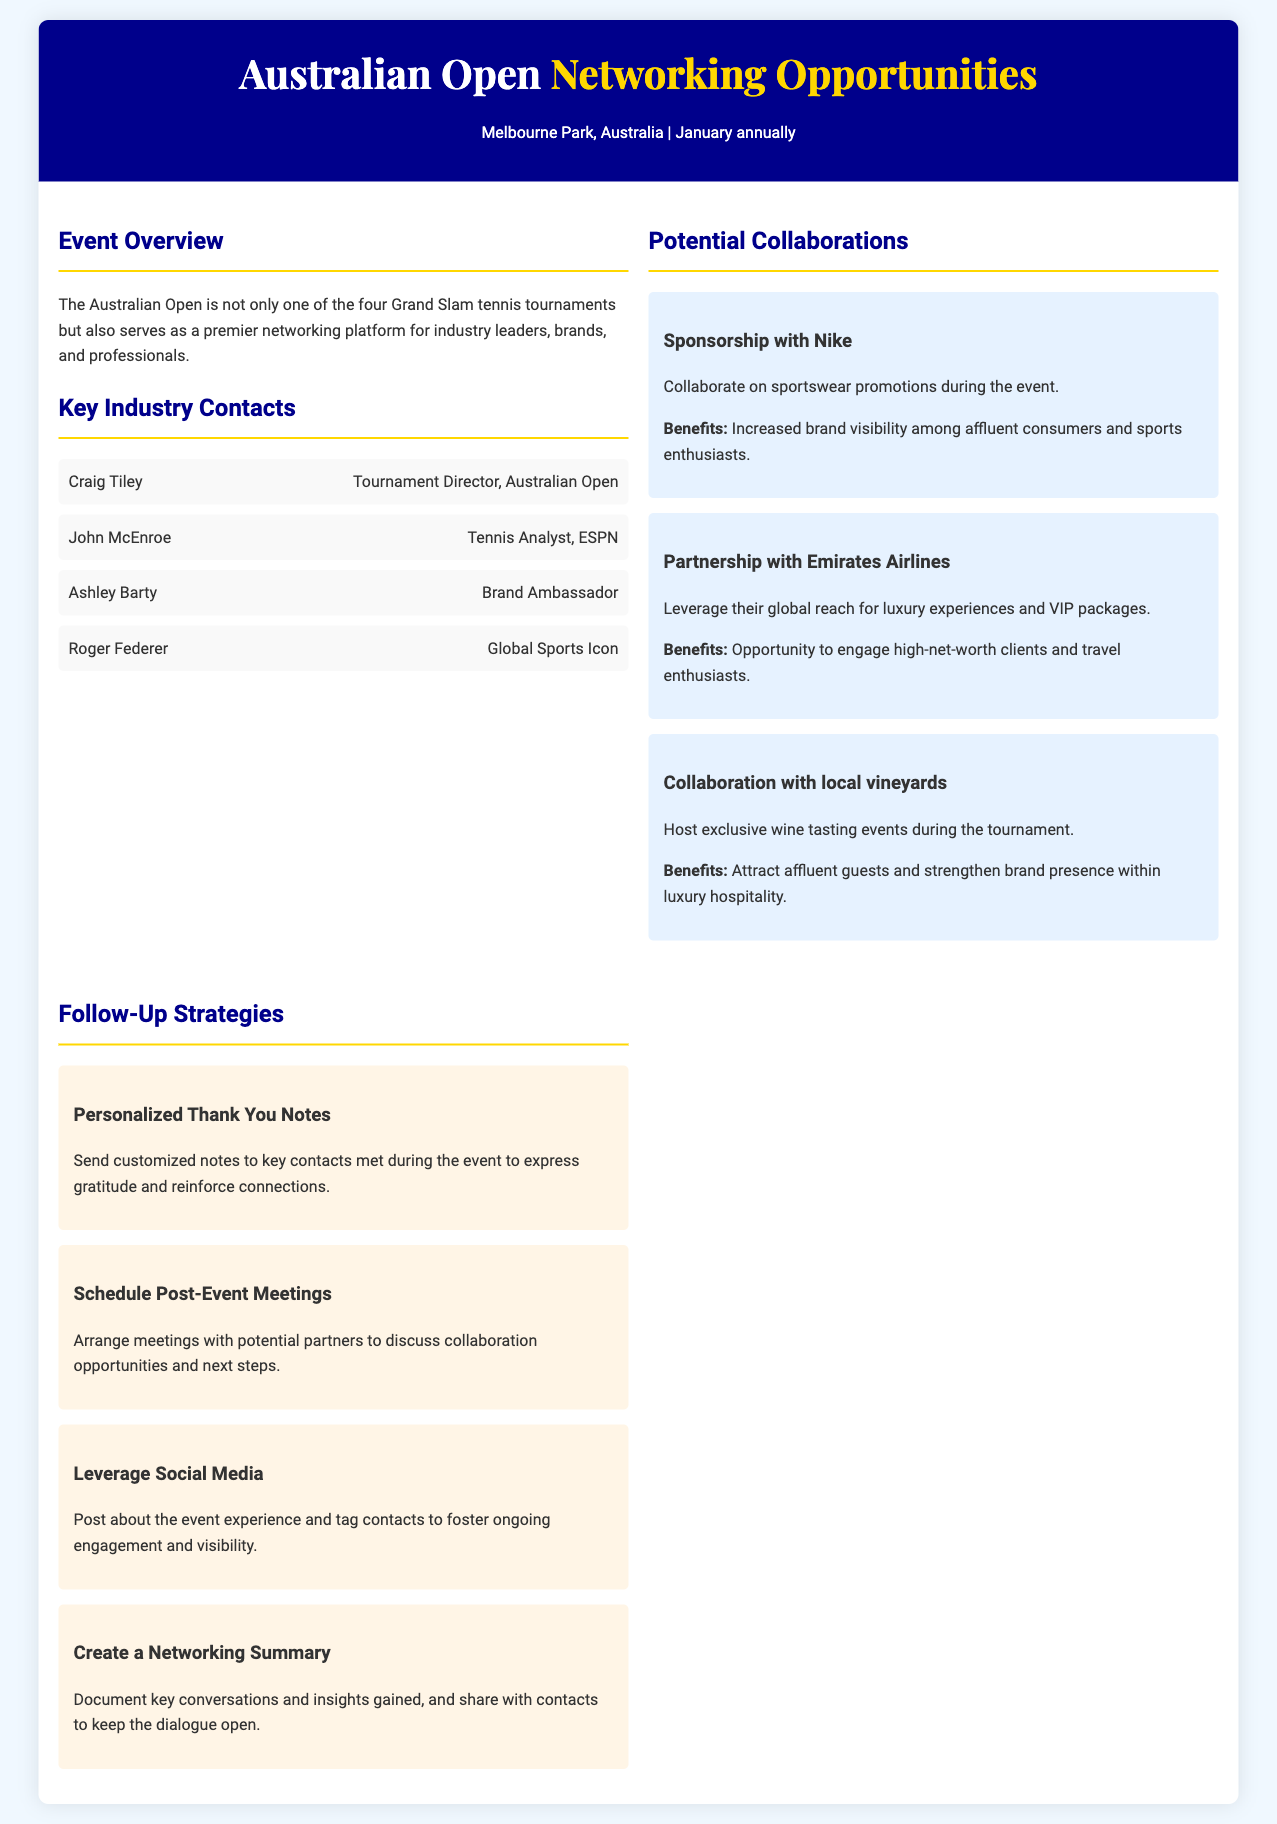what is the location of the Australian Open? The document states that the Australian Open takes place at Melbourne Park, Australia.
Answer: Melbourne Park, Australia who is the Tournament Director of the Australian Open? The document lists Craig Tiley as the Tournament Director.
Answer: Craig Tiley name one potential collaboration mentioned in the document. The document highlights several collaborations, one of which is with Nike for sportswear promotions.
Answer: Sponsorship with Nike how many key industry contacts are listed in the document? There are four key industry contacts mentioned in the document.
Answer: Four what is one follow-up strategy suggested for the networking opportunities? The document suggests various strategies, one of which is to send personalized thank you notes to key contacts.
Answer: Personalized Thank You Notes what is the benefit of collaborating with Emirates Airlines? The document states that collaborating with Emirates Airlines provides an opportunity to engage high-net-worth clients.
Answer: Engage high-net-worth clients which tennis analyst is mentioned in the document? The document mentions John McEnroe as the tennis analyst from ESPN.
Answer: John McEnroe how often does the Australian Open occur? The document indicates that the Australian Open occurs annually in January.
Answer: Annually 